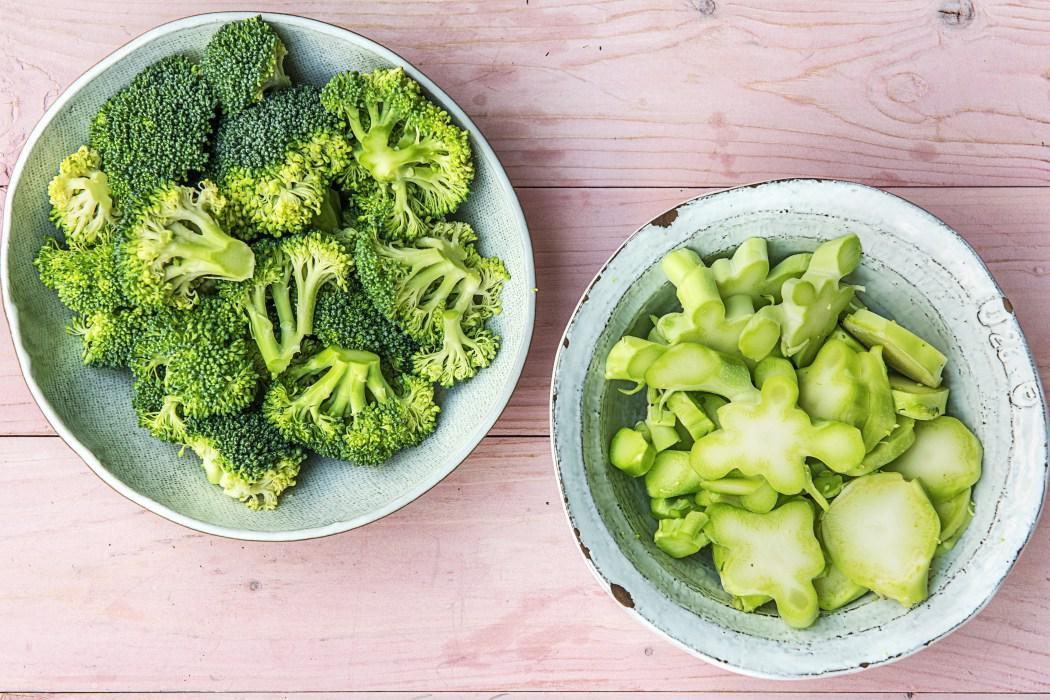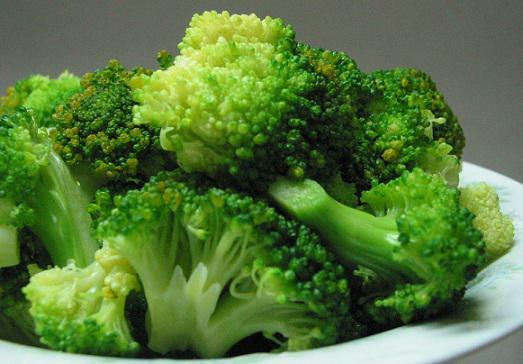The first image is the image on the left, the second image is the image on the right. Analyze the images presented: Is the assertion "One image shows broccoli florets still in the store packaging with a label on the front." valid? Answer yes or no. No. The first image is the image on the left, the second image is the image on the right. Evaluate the accuracy of this statement regarding the images: "The broccoli in one of the images is still in the bag.". Is it true? Answer yes or no. No. 